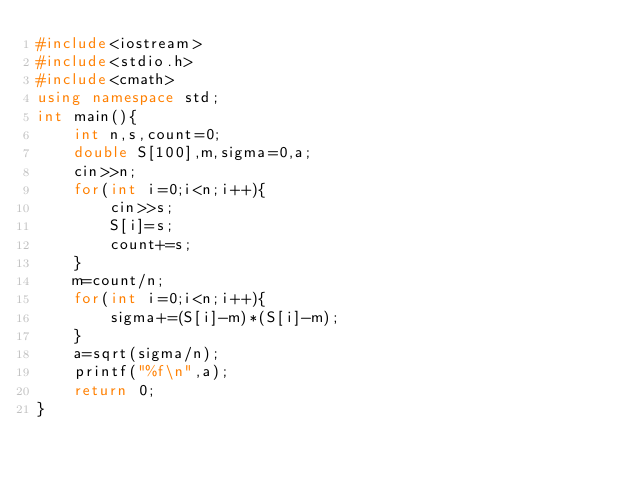Convert code to text. <code><loc_0><loc_0><loc_500><loc_500><_C++_>#include<iostream>
#include<stdio.h>
#include<cmath>
using namespace std;
int main(){
    int n,s,count=0;
    double S[100],m,sigma=0,a;
    cin>>n;
    for(int i=0;i<n;i++){
        cin>>s;
        S[i]=s;
        count+=s;
    }
    m=count/n;
    for(int i=0;i<n;i++){
        sigma+=(S[i]-m)*(S[i]-m);
    }
    a=sqrt(sigma/n);
    printf("%f\n",a);
    return 0;
}
</code> 